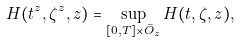Convert formula to latex. <formula><loc_0><loc_0><loc_500><loc_500>H ( t ^ { z } , \zeta ^ { z } , z ) = \sup _ { [ 0 , T ] \times \bar { O } _ { z } } H ( t , \zeta , z ) ,</formula> 